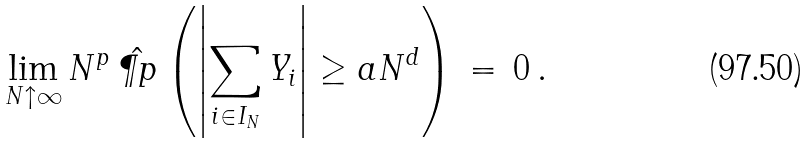Convert formula to latex. <formula><loc_0><loc_0><loc_500><loc_500>\lim _ { N \uparrow \infty } N ^ { p } \, \hat { \P p } \left ( \left | \sum _ { i \in I _ { N } } Y _ { i } \right | \geq a N ^ { d } \right ) \, = \, 0 \, .</formula> 